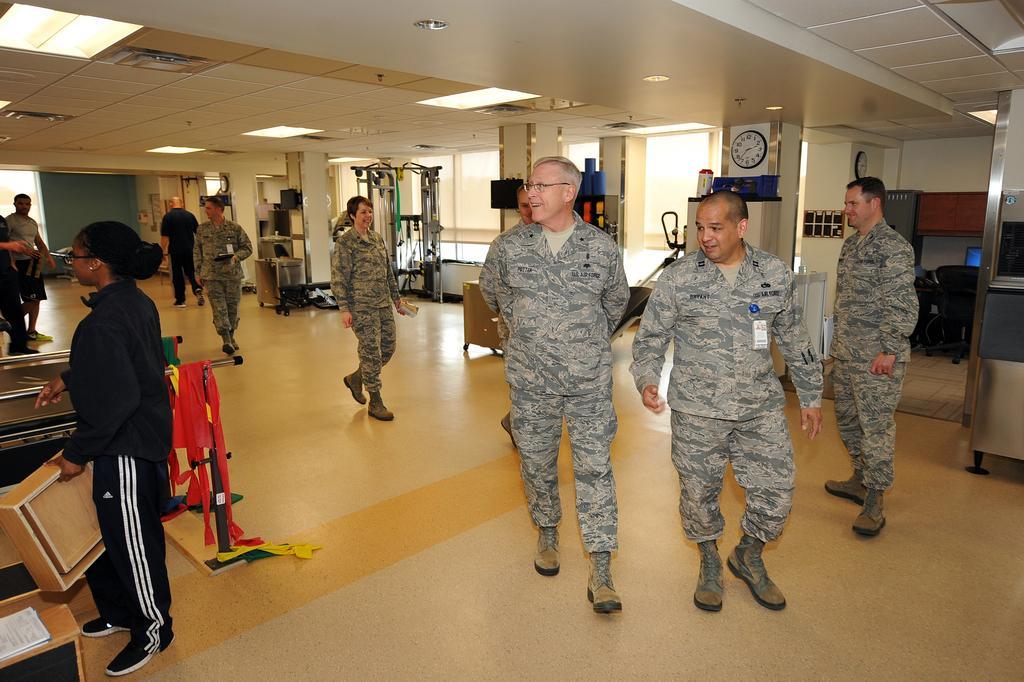Please provide a concise description of this image. This picture is an inside view of a room. In this picture we can see some persons, tablecloth, box, books, machine, clock, wall, pillars, board and some objects, rack. At the bottom of the image we can see the floor. At the top of the image we can see the roof and lights. In the middle of the image we can see windows. 